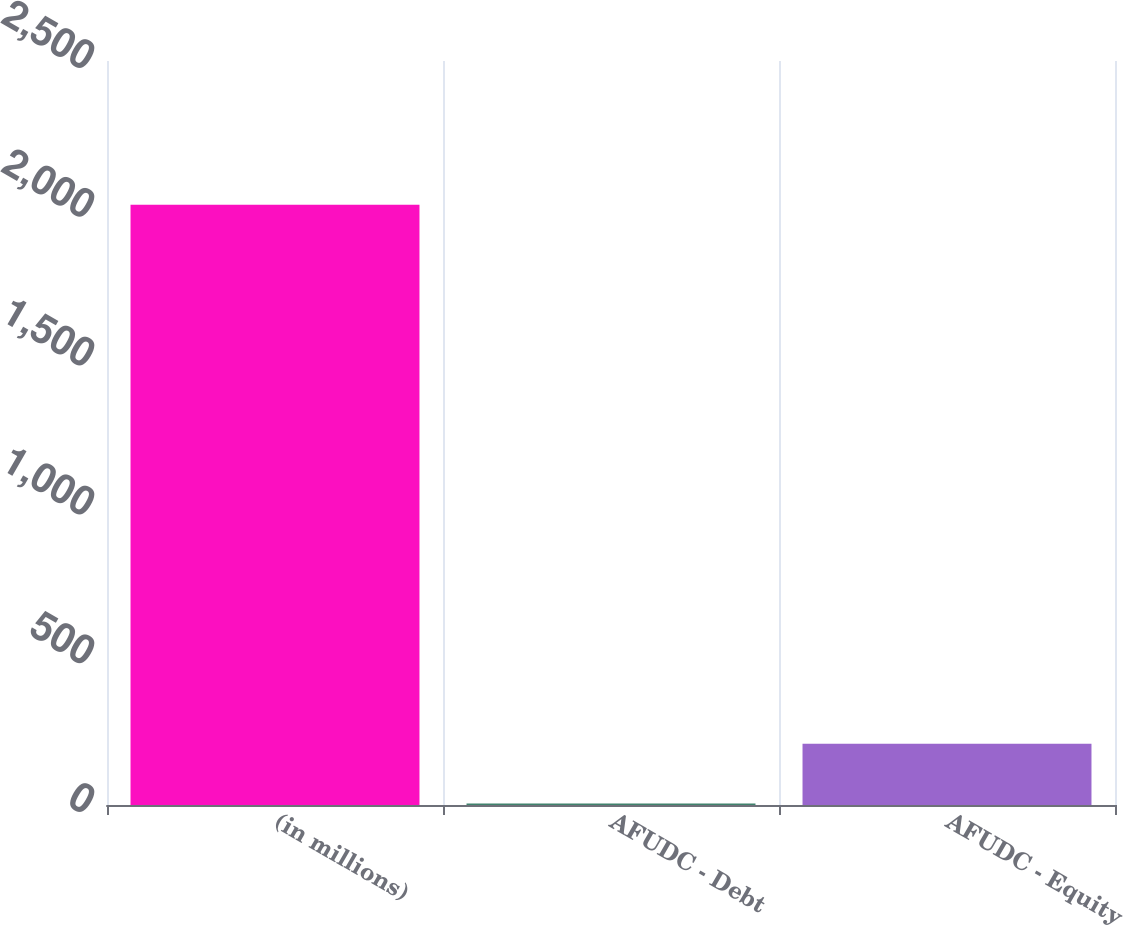Convert chart. <chart><loc_0><loc_0><loc_500><loc_500><bar_chart><fcel>(in millions)<fcel>AFUDC - Debt<fcel>AFUDC - Equity<nl><fcel>2017<fcel>4.9<fcel>206.11<nl></chart> 